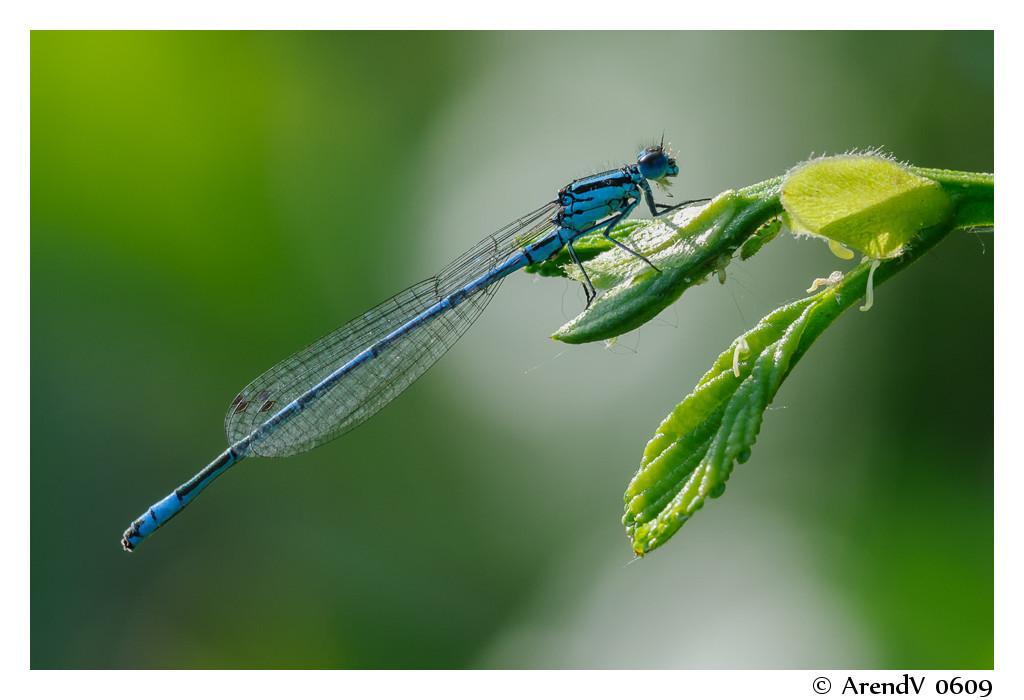Describe this image in one or two sentences. In this image I can see green colour leaves and on it I can see a blue colour dragonfly. I can also see green colour in the background and on the right bottom side I can see a watermark. I can also see this image is little bit blurry in the background. 